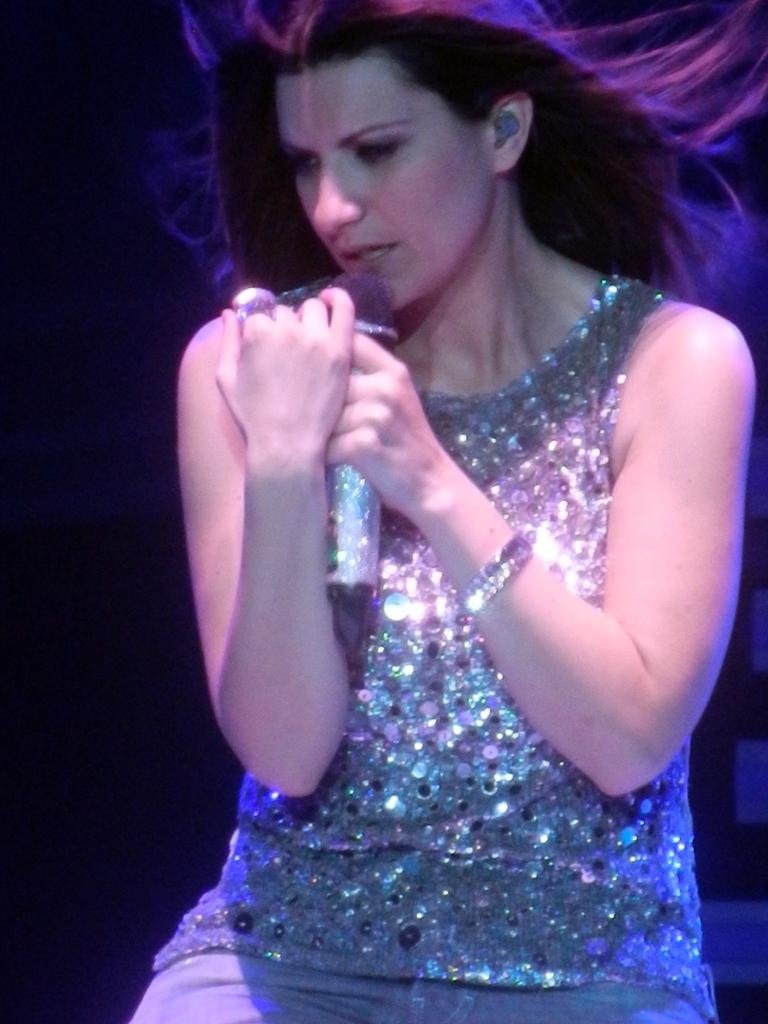What is the main subject of the image? The main subject of the image is a woman. What is the woman doing in the image? The woman is sitting and singing in the image. What is the woman holding in the image? The woman is holding a microphone in the image. How many objects can be seen behind the woman on the right side of the image? There are three objects behind the woman on the right side of the image. What is the color of the background in the image? The background of the image is dark. What type of company is the woman running in the image? There is no indication in the image that the woman is running a company or involved in any company-related activities. 